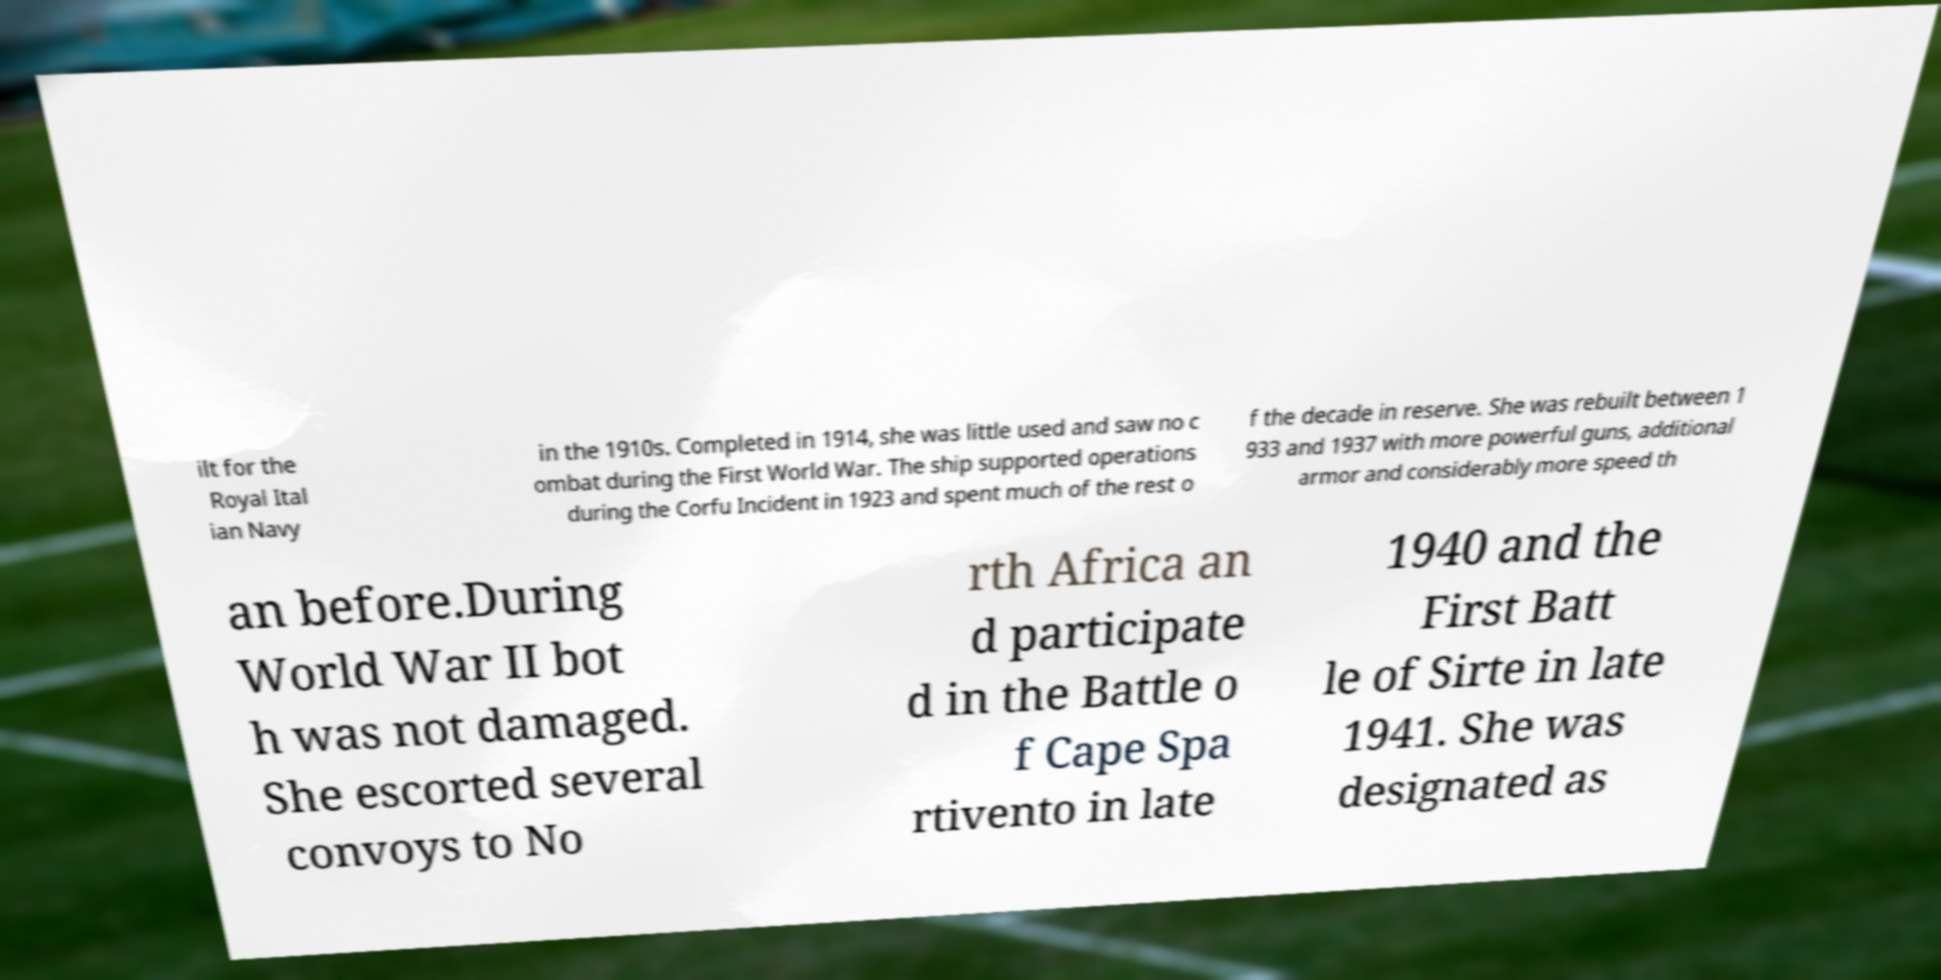Can you read and provide the text displayed in the image?This photo seems to have some interesting text. Can you extract and type it out for me? ilt for the Royal Ital ian Navy in the 1910s. Completed in 1914, she was little used and saw no c ombat during the First World War. The ship supported operations during the Corfu Incident in 1923 and spent much of the rest o f the decade in reserve. She was rebuilt between 1 933 and 1937 with more powerful guns, additional armor and considerably more speed th an before.During World War II bot h was not damaged. She escorted several convoys to No rth Africa an d participate d in the Battle o f Cape Spa rtivento in late 1940 and the First Batt le of Sirte in late 1941. She was designated as 